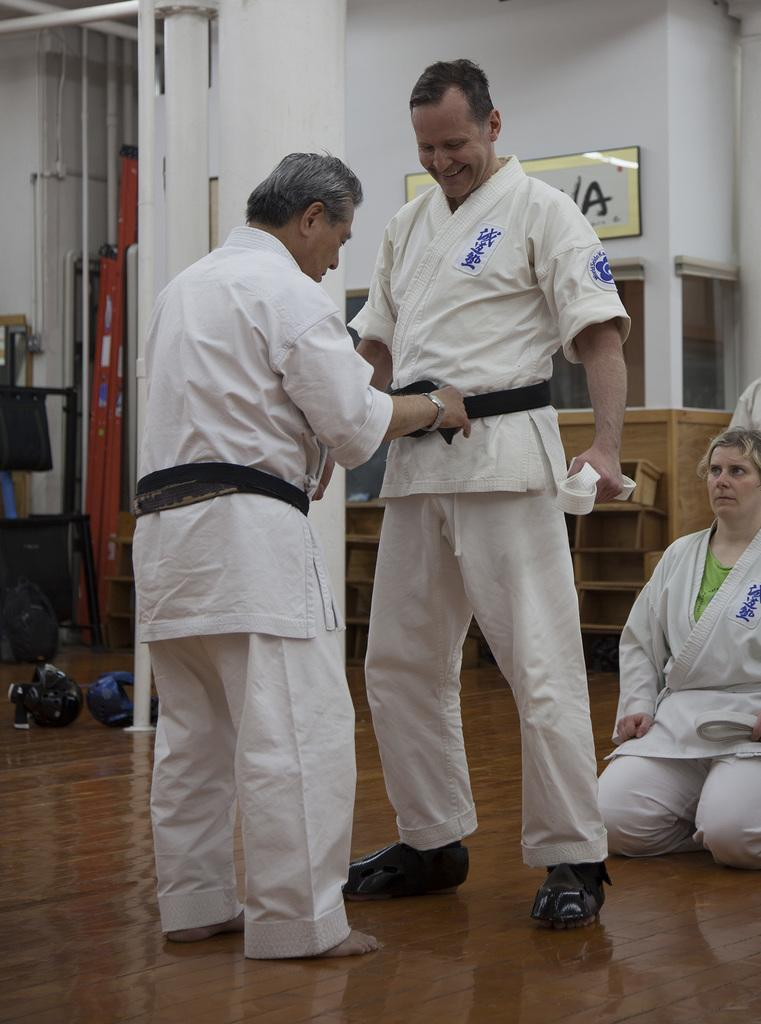<image>
Render a clear and concise summary of the photo. older man tightening belt of another judo participant that has a world seido patch on his sleeve 